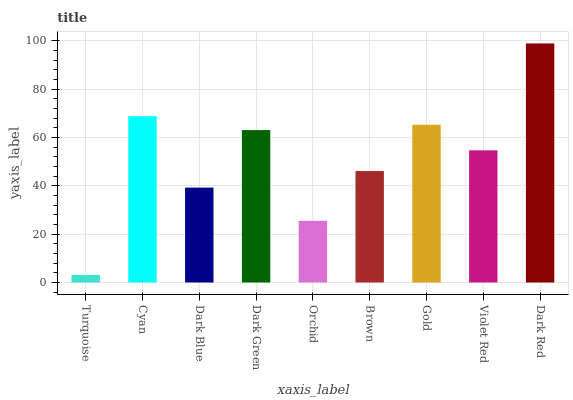Is Turquoise the minimum?
Answer yes or no. Yes. Is Dark Red the maximum?
Answer yes or no. Yes. Is Cyan the minimum?
Answer yes or no. No. Is Cyan the maximum?
Answer yes or no. No. Is Cyan greater than Turquoise?
Answer yes or no. Yes. Is Turquoise less than Cyan?
Answer yes or no. Yes. Is Turquoise greater than Cyan?
Answer yes or no. No. Is Cyan less than Turquoise?
Answer yes or no. No. Is Violet Red the high median?
Answer yes or no. Yes. Is Violet Red the low median?
Answer yes or no. Yes. Is Cyan the high median?
Answer yes or no. No. Is Dark Blue the low median?
Answer yes or no. No. 